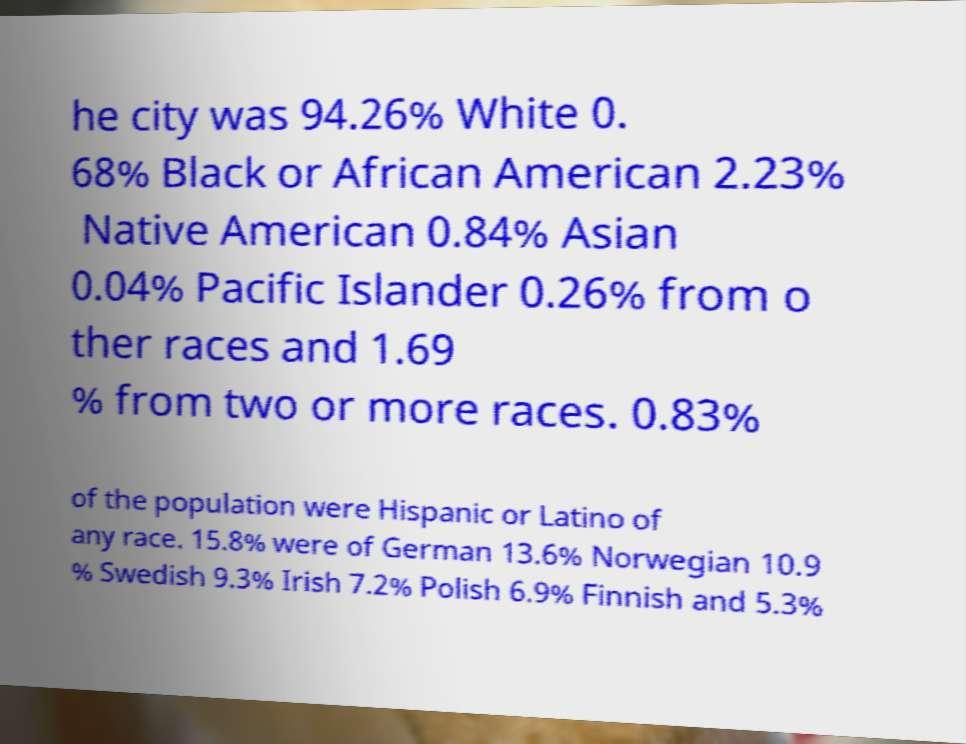Please identify and transcribe the text found in this image. he city was 94.26% White 0. 68% Black or African American 2.23% Native American 0.84% Asian 0.04% Pacific Islander 0.26% from o ther races and 1.69 % from two or more races. 0.83% of the population were Hispanic or Latino of any race. 15.8% were of German 13.6% Norwegian 10.9 % Swedish 9.3% Irish 7.2% Polish 6.9% Finnish and 5.3% 